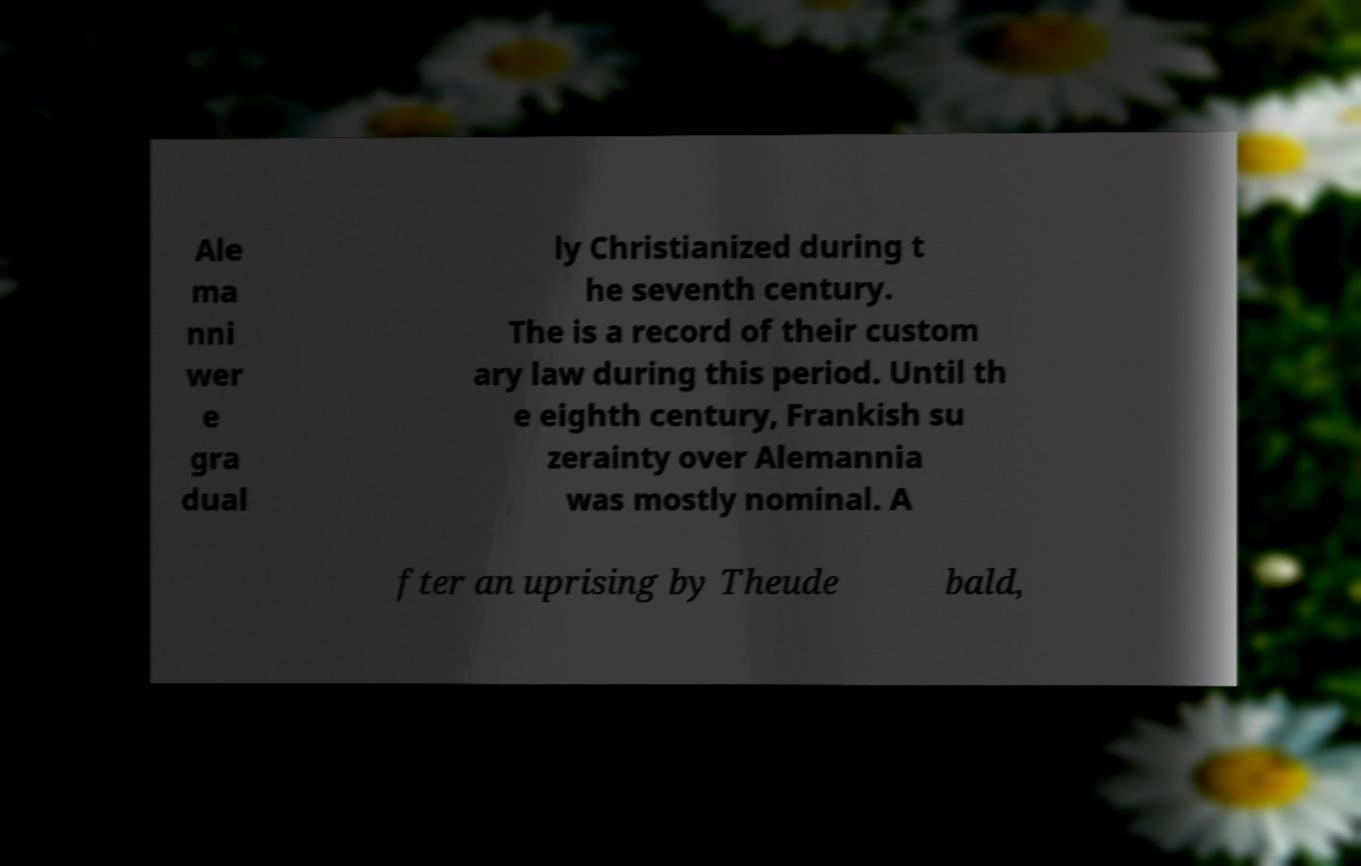Can you accurately transcribe the text from the provided image for me? Ale ma nni wer e gra dual ly Christianized during t he seventh century. The is a record of their custom ary law during this period. Until th e eighth century, Frankish su zerainty over Alemannia was mostly nominal. A fter an uprising by Theude bald, 